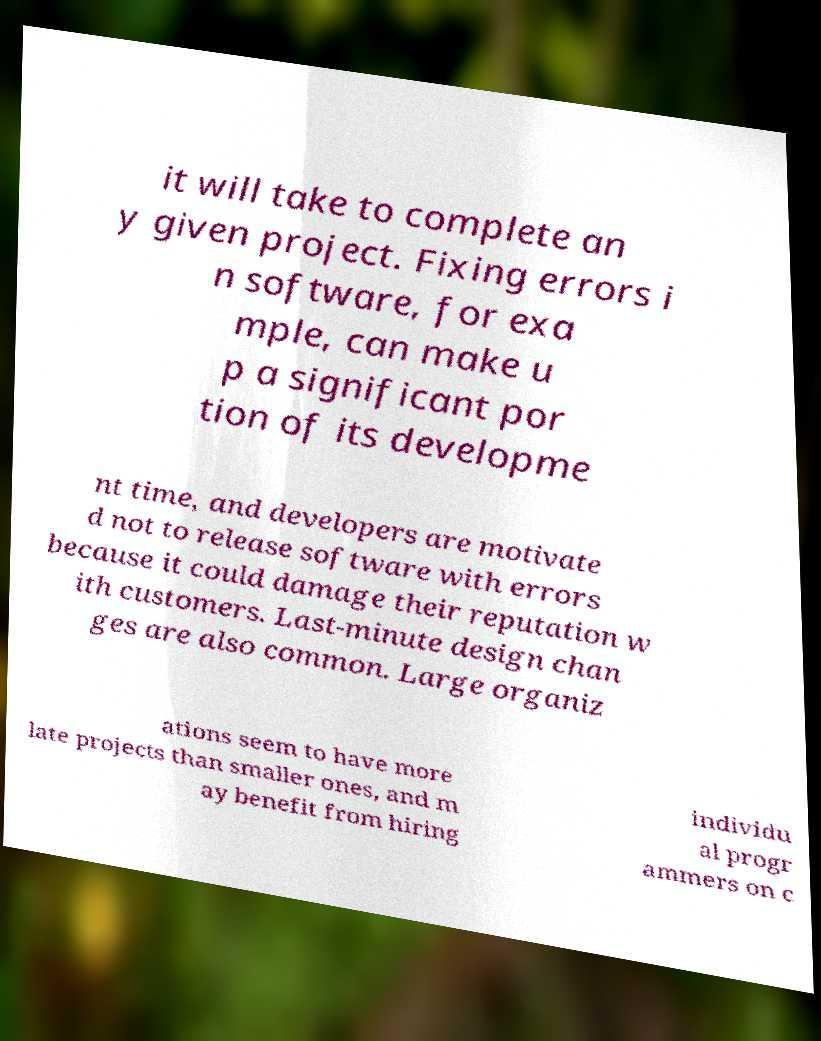Could you assist in decoding the text presented in this image and type it out clearly? it will take to complete an y given project. Fixing errors i n software, for exa mple, can make u p a significant por tion of its developme nt time, and developers are motivate d not to release software with errors because it could damage their reputation w ith customers. Last-minute design chan ges are also common. Large organiz ations seem to have more late projects than smaller ones, and m ay benefit from hiring individu al progr ammers on c 